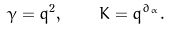<formula> <loc_0><loc_0><loc_500><loc_500>\gamma = q ^ { 2 } , \quad K = q ^ { \partial _ { \alpha } } .</formula> 